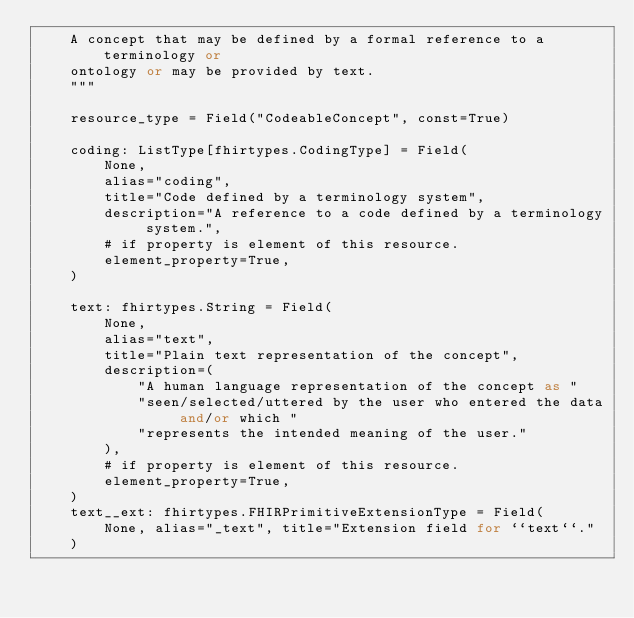<code> <loc_0><loc_0><loc_500><loc_500><_Python_>    A concept that may be defined by a formal reference to a terminology or
    ontology or may be provided by text.
    """

    resource_type = Field("CodeableConcept", const=True)

    coding: ListType[fhirtypes.CodingType] = Field(
        None,
        alias="coding",
        title="Code defined by a terminology system",
        description="A reference to a code defined by a terminology system.",
        # if property is element of this resource.
        element_property=True,
    )

    text: fhirtypes.String = Field(
        None,
        alias="text",
        title="Plain text representation of the concept",
        description=(
            "A human language representation of the concept as "
            "seen/selected/uttered by the user who entered the data and/or which "
            "represents the intended meaning of the user."
        ),
        # if property is element of this resource.
        element_property=True,
    )
    text__ext: fhirtypes.FHIRPrimitiveExtensionType = Field(
        None, alias="_text", title="Extension field for ``text``."
    )
</code> 